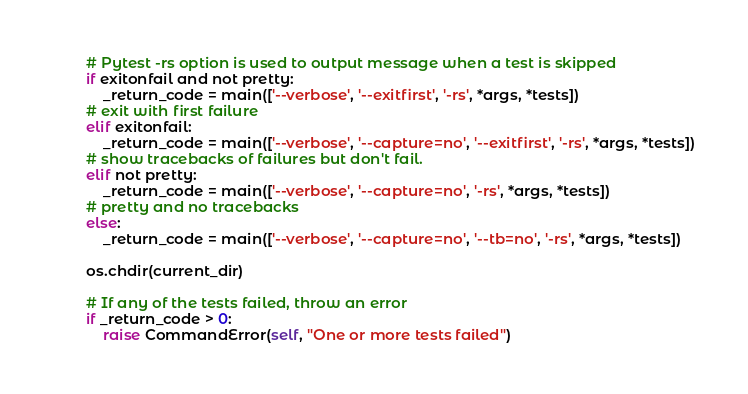Convert code to text. <code><loc_0><loc_0><loc_500><loc_500><_Python_>		# Pytest -rs option is used to output message when a test is skipped
		if exitonfail and not pretty:
			_return_code = main(['--verbose', '--exitfirst', '-rs', *args, *tests])
		# exit with first failure
		elif exitonfail:
			_return_code = main(['--verbose', '--capture=no', '--exitfirst', '-rs', *args, *tests])
		# show tracebacks of failures but don't fail.
		elif not pretty:
			_return_code = main(['--verbose', '--capture=no', '-rs', *args, *tests])
		# pretty and no tracebacks
		else:
			_return_code = main(['--verbose', '--capture=no', '--tb=no', '-rs', *args, *tests])

		os.chdir(current_dir)

		# If any of the tests failed, throw an error
		if _return_code > 0:
			raise CommandError(self, "One or more tests failed")
</code> 